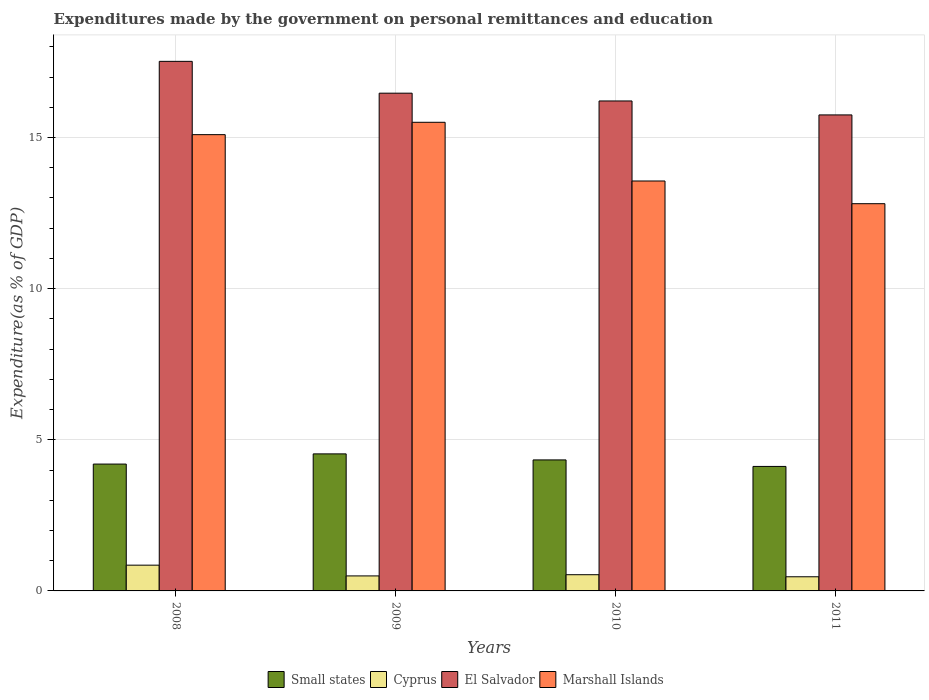How many bars are there on the 4th tick from the left?
Ensure brevity in your answer.  4. How many bars are there on the 1st tick from the right?
Your answer should be compact. 4. What is the expenditures made by the government on personal remittances and education in El Salvador in 2011?
Provide a succinct answer. 15.75. Across all years, what is the maximum expenditures made by the government on personal remittances and education in Small states?
Offer a very short reply. 4.53. Across all years, what is the minimum expenditures made by the government on personal remittances and education in Small states?
Give a very brief answer. 4.12. In which year was the expenditures made by the government on personal remittances and education in Cyprus minimum?
Provide a succinct answer. 2011. What is the total expenditures made by the government on personal remittances and education in El Salvador in the graph?
Make the answer very short. 65.95. What is the difference between the expenditures made by the government on personal remittances and education in Cyprus in 2009 and that in 2011?
Keep it short and to the point. 0.03. What is the difference between the expenditures made by the government on personal remittances and education in Marshall Islands in 2011 and the expenditures made by the government on personal remittances and education in El Salvador in 2010?
Offer a very short reply. -3.4. What is the average expenditures made by the government on personal remittances and education in Small states per year?
Offer a very short reply. 4.3. In the year 2011, what is the difference between the expenditures made by the government on personal remittances and education in Small states and expenditures made by the government on personal remittances and education in Cyprus?
Keep it short and to the point. 3.65. In how many years, is the expenditures made by the government on personal remittances and education in El Salvador greater than 10 %?
Your answer should be very brief. 4. What is the ratio of the expenditures made by the government on personal remittances and education in Cyprus in 2009 to that in 2011?
Offer a terse response. 1.06. Is the expenditures made by the government on personal remittances and education in El Salvador in 2008 less than that in 2011?
Provide a short and direct response. No. Is the difference between the expenditures made by the government on personal remittances and education in Small states in 2009 and 2010 greater than the difference between the expenditures made by the government on personal remittances and education in Cyprus in 2009 and 2010?
Your answer should be compact. Yes. What is the difference between the highest and the second highest expenditures made by the government on personal remittances and education in Marshall Islands?
Offer a terse response. 0.41. What is the difference between the highest and the lowest expenditures made by the government on personal remittances and education in Marshall Islands?
Your answer should be compact. 2.69. Is it the case that in every year, the sum of the expenditures made by the government on personal remittances and education in El Salvador and expenditures made by the government on personal remittances and education in Small states is greater than the sum of expenditures made by the government on personal remittances and education in Marshall Islands and expenditures made by the government on personal remittances and education in Cyprus?
Make the answer very short. Yes. What does the 3rd bar from the left in 2009 represents?
Keep it short and to the point. El Salvador. What does the 2nd bar from the right in 2009 represents?
Provide a short and direct response. El Salvador. Where does the legend appear in the graph?
Your answer should be compact. Bottom center. How are the legend labels stacked?
Give a very brief answer. Horizontal. What is the title of the graph?
Ensure brevity in your answer.  Expenditures made by the government on personal remittances and education. Does "Egypt, Arab Rep." appear as one of the legend labels in the graph?
Ensure brevity in your answer.  No. What is the label or title of the Y-axis?
Your answer should be compact. Expenditure(as % of GDP). What is the Expenditure(as % of GDP) of Small states in 2008?
Offer a terse response. 4.2. What is the Expenditure(as % of GDP) of Cyprus in 2008?
Your answer should be very brief. 0.85. What is the Expenditure(as % of GDP) in El Salvador in 2008?
Keep it short and to the point. 17.52. What is the Expenditure(as % of GDP) of Marshall Islands in 2008?
Give a very brief answer. 15.1. What is the Expenditure(as % of GDP) in Small states in 2009?
Provide a short and direct response. 4.53. What is the Expenditure(as % of GDP) of Cyprus in 2009?
Make the answer very short. 0.5. What is the Expenditure(as % of GDP) in El Salvador in 2009?
Your response must be concise. 16.47. What is the Expenditure(as % of GDP) of Marshall Islands in 2009?
Your response must be concise. 15.5. What is the Expenditure(as % of GDP) in Small states in 2010?
Your answer should be very brief. 4.33. What is the Expenditure(as % of GDP) of Cyprus in 2010?
Make the answer very short. 0.54. What is the Expenditure(as % of GDP) of El Salvador in 2010?
Your answer should be compact. 16.21. What is the Expenditure(as % of GDP) in Marshall Islands in 2010?
Provide a succinct answer. 13.56. What is the Expenditure(as % of GDP) in Small states in 2011?
Offer a very short reply. 4.12. What is the Expenditure(as % of GDP) of Cyprus in 2011?
Offer a very short reply. 0.47. What is the Expenditure(as % of GDP) in El Salvador in 2011?
Keep it short and to the point. 15.75. What is the Expenditure(as % of GDP) of Marshall Islands in 2011?
Keep it short and to the point. 12.81. Across all years, what is the maximum Expenditure(as % of GDP) in Small states?
Your answer should be compact. 4.53. Across all years, what is the maximum Expenditure(as % of GDP) in Cyprus?
Offer a terse response. 0.85. Across all years, what is the maximum Expenditure(as % of GDP) in El Salvador?
Offer a terse response. 17.52. Across all years, what is the maximum Expenditure(as % of GDP) in Marshall Islands?
Offer a very short reply. 15.5. Across all years, what is the minimum Expenditure(as % of GDP) in Small states?
Keep it short and to the point. 4.12. Across all years, what is the minimum Expenditure(as % of GDP) of Cyprus?
Offer a terse response. 0.47. Across all years, what is the minimum Expenditure(as % of GDP) of El Salvador?
Ensure brevity in your answer.  15.75. Across all years, what is the minimum Expenditure(as % of GDP) of Marshall Islands?
Your response must be concise. 12.81. What is the total Expenditure(as % of GDP) of Small states in the graph?
Your answer should be compact. 17.18. What is the total Expenditure(as % of GDP) in Cyprus in the graph?
Offer a terse response. 2.35. What is the total Expenditure(as % of GDP) of El Salvador in the graph?
Offer a very short reply. 65.95. What is the total Expenditure(as % of GDP) in Marshall Islands in the graph?
Your response must be concise. 56.97. What is the difference between the Expenditure(as % of GDP) in Small states in 2008 and that in 2009?
Give a very brief answer. -0.34. What is the difference between the Expenditure(as % of GDP) of Cyprus in 2008 and that in 2009?
Make the answer very short. 0.36. What is the difference between the Expenditure(as % of GDP) of El Salvador in 2008 and that in 2009?
Provide a succinct answer. 1.05. What is the difference between the Expenditure(as % of GDP) of Marshall Islands in 2008 and that in 2009?
Provide a succinct answer. -0.41. What is the difference between the Expenditure(as % of GDP) in Small states in 2008 and that in 2010?
Ensure brevity in your answer.  -0.14. What is the difference between the Expenditure(as % of GDP) in Cyprus in 2008 and that in 2010?
Your response must be concise. 0.32. What is the difference between the Expenditure(as % of GDP) of El Salvador in 2008 and that in 2010?
Your answer should be compact. 1.31. What is the difference between the Expenditure(as % of GDP) in Marshall Islands in 2008 and that in 2010?
Offer a very short reply. 1.53. What is the difference between the Expenditure(as % of GDP) in Small states in 2008 and that in 2011?
Make the answer very short. 0.08. What is the difference between the Expenditure(as % of GDP) in Cyprus in 2008 and that in 2011?
Provide a short and direct response. 0.38. What is the difference between the Expenditure(as % of GDP) of El Salvador in 2008 and that in 2011?
Your answer should be very brief. 1.77. What is the difference between the Expenditure(as % of GDP) in Marshall Islands in 2008 and that in 2011?
Make the answer very short. 2.28. What is the difference between the Expenditure(as % of GDP) of Small states in 2009 and that in 2010?
Give a very brief answer. 0.2. What is the difference between the Expenditure(as % of GDP) of Cyprus in 2009 and that in 2010?
Offer a very short reply. -0.04. What is the difference between the Expenditure(as % of GDP) in El Salvador in 2009 and that in 2010?
Your response must be concise. 0.26. What is the difference between the Expenditure(as % of GDP) in Marshall Islands in 2009 and that in 2010?
Make the answer very short. 1.94. What is the difference between the Expenditure(as % of GDP) of Small states in 2009 and that in 2011?
Make the answer very short. 0.42. What is the difference between the Expenditure(as % of GDP) of Cyprus in 2009 and that in 2011?
Offer a terse response. 0.03. What is the difference between the Expenditure(as % of GDP) in El Salvador in 2009 and that in 2011?
Offer a very short reply. 0.72. What is the difference between the Expenditure(as % of GDP) of Marshall Islands in 2009 and that in 2011?
Provide a succinct answer. 2.69. What is the difference between the Expenditure(as % of GDP) in Small states in 2010 and that in 2011?
Offer a very short reply. 0.22. What is the difference between the Expenditure(as % of GDP) of Cyprus in 2010 and that in 2011?
Offer a very short reply. 0.07. What is the difference between the Expenditure(as % of GDP) of El Salvador in 2010 and that in 2011?
Ensure brevity in your answer.  0.46. What is the difference between the Expenditure(as % of GDP) of Marshall Islands in 2010 and that in 2011?
Give a very brief answer. 0.75. What is the difference between the Expenditure(as % of GDP) of Small states in 2008 and the Expenditure(as % of GDP) of Cyprus in 2009?
Your answer should be very brief. 3.7. What is the difference between the Expenditure(as % of GDP) of Small states in 2008 and the Expenditure(as % of GDP) of El Salvador in 2009?
Offer a very short reply. -12.27. What is the difference between the Expenditure(as % of GDP) of Small states in 2008 and the Expenditure(as % of GDP) of Marshall Islands in 2009?
Make the answer very short. -11.31. What is the difference between the Expenditure(as % of GDP) in Cyprus in 2008 and the Expenditure(as % of GDP) in El Salvador in 2009?
Your answer should be very brief. -15.62. What is the difference between the Expenditure(as % of GDP) of Cyprus in 2008 and the Expenditure(as % of GDP) of Marshall Islands in 2009?
Your answer should be compact. -14.65. What is the difference between the Expenditure(as % of GDP) of El Salvador in 2008 and the Expenditure(as % of GDP) of Marshall Islands in 2009?
Your response must be concise. 2.02. What is the difference between the Expenditure(as % of GDP) of Small states in 2008 and the Expenditure(as % of GDP) of Cyprus in 2010?
Make the answer very short. 3.66. What is the difference between the Expenditure(as % of GDP) of Small states in 2008 and the Expenditure(as % of GDP) of El Salvador in 2010?
Your response must be concise. -12.01. What is the difference between the Expenditure(as % of GDP) of Small states in 2008 and the Expenditure(as % of GDP) of Marshall Islands in 2010?
Provide a succinct answer. -9.37. What is the difference between the Expenditure(as % of GDP) in Cyprus in 2008 and the Expenditure(as % of GDP) in El Salvador in 2010?
Offer a terse response. -15.36. What is the difference between the Expenditure(as % of GDP) of Cyprus in 2008 and the Expenditure(as % of GDP) of Marshall Islands in 2010?
Ensure brevity in your answer.  -12.71. What is the difference between the Expenditure(as % of GDP) in El Salvador in 2008 and the Expenditure(as % of GDP) in Marshall Islands in 2010?
Keep it short and to the point. 3.96. What is the difference between the Expenditure(as % of GDP) in Small states in 2008 and the Expenditure(as % of GDP) in Cyprus in 2011?
Provide a short and direct response. 3.73. What is the difference between the Expenditure(as % of GDP) of Small states in 2008 and the Expenditure(as % of GDP) of El Salvador in 2011?
Provide a succinct answer. -11.55. What is the difference between the Expenditure(as % of GDP) in Small states in 2008 and the Expenditure(as % of GDP) in Marshall Islands in 2011?
Provide a succinct answer. -8.61. What is the difference between the Expenditure(as % of GDP) in Cyprus in 2008 and the Expenditure(as % of GDP) in El Salvador in 2011?
Give a very brief answer. -14.9. What is the difference between the Expenditure(as % of GDP) of Cyprus in 2008 and the Expenditure(as % of GDP) of Marshall Islands in 2011?
Your answer should be compact. -11.96. What is the difference between the Expenditure(as % of GDP) in El Salvador in 2008 and the Expenditure(as % of GDP) in Marshall Islands in 2011?
Make the answer very short. 4.71. What is the difference between the Expenditure(as % of GDP) of Small states in 2009 and the Expenditure(as % of GDP) of Cyprus in 2010?
Offer a terse response. 4. What is the difference between the Expenditure(as % of GDP) of Small states in 2009 and the Expenditure(as % of GDP) of El Salvador in 2010?
Offer a terse response. -11.68. What is the difference between the Expenditure(as % of GDP) in Small states in 2009 and the Expenditure(as % of GDP) in Marshall Islands in 2010?
Offer a terse response. -9.03. What is the difference between the Expenditure(as % of GDP) in Cyprus in 2009 and the Expenditure(as % of GDP) in El Salvador in 2010?
Offer a very short reply. -15.71. What is the difference between the Expenditure(as % of GDP) of Cyprus in 2009 and the Expenditure(as % of GDP) of Marshall Islands in 2010?
Give a very brief answer. -13.07. What is the difference between the Expenditure(as % of GDP) in El Salvador in 2009 and the Expenditure(as % of GDP) in Marshall Islands in 2010?
Keep it short and to the point. 2.91. What is the difference between the Expenditure(as % of GDP) in Small states in 2009 and the Expenditure(as % of GDP) in Cyprus in 2011?
Keep it short and to the point. 4.07. What is the difference between the Expenditure(as % of GDP) in Small states in 2009 and the Expenditure(as % of GDP) in El Salvador in 2011?
Ensure brevity in your answer.  -11.21. What is the difference between the Expenditure(as % of GDP) in Small states in 2009 and the Expenditure(as % of GDP) in Marshall Islands in 2011?
Your answer should be compact. -8.28. What is the difference between the Expenditure(as % of GDP) in Cyprus in 2009 and the Expenditure(as % of GDP) in El Salvador in 2011?
Offer a very short reply. -15.25. What is the difference between the Expenditure(as % of GDP) of Cyprus in 2009 and the Expenditure(as % of GDP) of Marshall Islands in 2011?
Make the answer very short. -12.31. What is the difference between the Expenditure(as % of GDP) in El Salvador in 2009 and the Expenditure(as % of GDP) in Marshall Islands in 2011?
Keep it short and to the point. 3.66. What is the difference between the Expenditure(as % of GDP) in Small states in 2010 and the Expenditure(as % of GDP) in Cyprus in 2011?
Offer a very short reply. 3.87. What is the difference between the Expenditure(as % of GDP) of Small states in 2010 and the Expenditure(as % of GDP) of El Salvador in 2011?
Offer a terse response. -11.41. What is the difference between the Expenditure(as % of GDP) in Small states in 2010 and the Expenditure(as % of GDP) in Marshall Islands in 2011?
Offer a very short reply. -8.48. What is the difference between the Expenditure(as % of GDP) in Cyprus in 2010 and the Expenditure(as % of GDP) in El Salvador in 2011?
Make the answer very short. -15.21. What is the difference between the Expenditure(as % of GDP) of Cyprus in 2010 and the Expenditure(as % of GDP) of Marshall Islands in 2011?
Provide a succinct answer. -12.27. What is the difference between the Expenditure(as % of GDP) in El Salvador in 2010 and the Expenditure(as % of GDP) in Marshall Islands in 2011?
Keep it short and to the point. 3.4. What is the average Expenditure(as % of GDP) of Small states per year?
Provide a short and direct response. 4.3. What is the average Expenditure(as % of GDP) in Cyprus per year?
Keep it short and to the point. 0.59. What is the average Expenditure(as % of GDP) of El Salvador per year?
Offer a very short reply. 16.49. What is the average Expenditure(as % of GDP) in Marshall Islands per year?
Make the answer very short. 14.24. In the year 2008, what is the difference between the Expenditure(as % of GDP) of Small states and Expenditure(as % of GDP) of Cyprus?
Your answer should be compact. 3.34. In the year 2008, what is the difference between the Expenditure(as % of GDP) of Small states and Expenditure(as % of GDP) of El Salvador?
Your answer should be compact. -13.32. In the year 2008, what is the difference between the Expenditure(as % of GDP) of Small states and Expenditure(as % of GDP) of Marshall Islands?
Your answer should be compact. -10.9. In the year 2008, what is the difference between the Expenditure(as % of GDP) of Cyprus and Expenditure(as % of GDP) of El Salvador?
Your response must be concise. -16.67. In the year 2008, what is the difference between the Expenditure(as % of GDP) in Cyprus and Expenditure(as % of GDP) in Marshall Islands?
Make the answer very short. -14.24. In the year 2008, what is the difference between the Expenditure(as % of GDP) of El Salvador and Expenditure(as % of GDP) of Marshall Islands?
Offer a terse response. 2.42. In the year 2009, what is the difference between the Expenditure(as % of GDP) in Small states and Expenditure(as % of GDP) in Cyprus?
Offer a very short reply. 4.04. In the year 2009, what is the difference between the Expenditure(as % of GDP) of Small states and Expenditure(as % of GDP) of El Salvador?
Offer a terse response. -11.93. In the year 2009, what is the difference between the Expenditure(as % of GDP) in Small states and Expenditure(as % of GDP) in Marshall Islands?
Keep it short and to the point. -10.97. In the year 2009, what is the difference between the Expenditure(as % of GDP) in Cyprus and Expenditure(as % of GDP) in El Salvador?
Provide a succinct answer. -15.97. In the year 2009, what is the difference between the Expenditure(as % of GDP) in Cyprus and Expenditure(as % of GDP) in Marshall Islands?
Make the answer very short. -15.01. In the year 2009, what is the difference between the Expenditure(as % of GDP) of El Salvador and Expenditure(as % of GDP) of Marshall Islands?
Provide a succinct answer. 0.96. In the year 2010, what is the difference between the Expenditure(as % of GDP) in Small states and Expenditure(as % of GDP) in Cyprus?
Give a very brief answer. 3.8. In the year 2010, what is the difference between the Expenditure(as % of GDP) in Small states and Expenditure(as % of GDP) in El Salvador?
Provide a succinct answer. -11.88. In the year 2010, what is the difference between the Expenditure(as % of GDP) of Small states and Expenditure(as % of GDP) of Marshall Islands?
Ensure brevity in your answer.  -9.23. In the year 2010, what is the difference between the Expenditure(as % of GDP) in Cyprus and Expenditure(as % of GDP) in El Salvador?
Your answer should be compact. -15.67. In the year 2010, what is the difference between the Expenditure(as % of GDP) of Cyprus and Expenditure(as % of GDP) of Marshall Islands?
Ensure brevity in your answer.  -13.03. In the year 2010, what is the difference between the Expenditure(as % of GDP) of El Salvador and Expenditure(as % of GDP) of Marshall Islands?
Your answer should be compact. 2.65. In the year 2011, what is the difference between the Expenditure(as % of GDP) of Small states and Expenditure(as % of GDP) of Cyprus?
Offer a very short reply. 3.65. In the year 2011, what is the difference between the Expenditure(as % of GDP) of Small states and Expenditure(as % of GDP) of El Salvador?
Offer a terse response. -11.63. In the year 2011, what is the difference between the Expenditure(as % of GDP) of Small states and Expenditure(as % of GDP) of Marshall Islands?
Make the answer very short. -8.69. In the year 2011, what is the difference between the Expenditure(as % of GDP) in Cyprus and Expenditure(as % of GDP) in El Salvador?
Your answer should be compact. -15.28. In the year 2011, what is the difference between the Expenditure(as % of GDP) of Cyprus and Expenditure(as % of GDP) of Marshall Islands?
Offer a very short reply. -12.34. In the year 2011, what is the difference between the Expenditure(as % of GDP) in El Salvador and Expenditure(as % of GDP) in Marshall Islands?
Offer a very short reply. 2.94. What is the ratio of the Expenditure(as % of GDP) in Small states in 2008 to that in 2009?
Your response must be concise. 0.93. What is the ratio of the Expenditure(as % of GDP) of Cyprus in 2008 to that in 2009?
Your answer should be compact. 1.72. What is the ratio of the Expenditure(as % of GDP) in El Salvador in 2008 to that in 2009?
Offer a very short reply. 1.06. What is the ratio of the Expenditure(as % of GDP) of Marshall Islands in 2008 to that in 2009?
Keep it short and to the point. 0.97. What is the ratio of the Expenditure(as % of GDP) of Small states in 2008 to that in 2010?
Your answer should be very brief. 0.97. What is the ratio of the Expenditure(as % of GDP) of Cyprus in 2008 to that in 2010?
Make the answer very short. 1.59. What is the ratio of the Expenditure(as % of GDP) in El Salvador in 2008 to that in 2010?
Your answer should be compact. 1.08. What is the ratio of the Expenditure(as % of GDP) in Marshall Islands in 2008 to that in 2010?
Give a very brief answer. 1.11. What is the ratio of the Expenditure(as % of GDP) of Small states in 2008 to that in 2011?
Ensure brevity in your answer.  1.02. What is the ratio of the Expenditure(as % of GDP) of Cyprus in 2008 to that in 2011?
Make the answer very short. 1.82. What is the ratio of the Expenditure(as % of GDP) in El Salvador in 2008 to that in 2011?
Offer a terse response. 1.11. What is the ratio of the Expenditure(as % of GDP) of Marshall Islands in 2008 to that in 2011?
Offer a very short reply. 1.18. What is the ratio of the Expenditure(as % of GDP) of Small states in 2009 to that in 2010?
Ensure brevity in your answer.  1.05. What is the ratio of the Expenditure(as % of GDP) of Cyprus in 2009 to that in 2010?
Provide a short and direct response. 0.93. What is the ratio of the Expenditure(as % of GDP) of El Salvador in 2009 to that in 2010?
Offer a very short reply. 1.02. What is the ratio of the Expenditure(as % of GDP) in Marshall Islands in 2009 to that in 2010?
Your response must be concise. 1.14. What is the ratio of the Expenditure(as % of GDP) of Small states in 2009 to that in 2011?
Give a very brief answer. 1.1. What is the ratio of the Expenditure(as % of GDP) in Cyprus in 2009 to that in 2011?
Make the answer very short. 1.06. What is the ratio of the Expenditure(as % of GDP) of El Salvador in 2009 to that in 2011?
Your answer should be very brief. 1.05. What is the ratio of the Expenditure(as % of GDP) in Marshall Islands in 2009 to that in 2011?
Provide a short and direct response. 1.21. What is the ratio of the Expenditure(as % of GDP) in Small states in 2010 to that in 2011?
Offer a very short reply. 1.05. What is the ratio of the Expenditure(as % of GDP) in Cyprus in 2010 to that in 2011?
Your answer should be compact. 1.15. What is the ratio of the Expenditure(as % of GDP) in El Salvador in 2010 to that in 2011?
Provide a succinct answer. 1.03. What is the ratio of the Expenditure(as % of GDP) in Marshall Islands in 2010 to that in 2011?
Ensure brevity in your answer.  1.06. What is the difference between the highest and the second highest Expenditure(as % of GDP) in Small states?
Your response must be concise. 0.2. What is the difference between the highest and the second highest Expenditure(as % of GDP) of Cyprus?
Keep it short and to the point. 0.32. What is the difference between the highest and the second highest Expenditure(as % of GDP) in El Salvador?
Your answer should be very brief. 1.05. What is the difference between the highest and the second highest Expenditure(as % of GDP) of Marshall Islands?
Ensure brevity in your answer.  0.41. What is the difference between the highest and the lowest Expenditure(as % of GDP) in Small states?
Ensure brevity in your answer.  0.42. What is the difference between the highest and the lowest Expenditure(as % of GDP) of Cyprus?
Your answer should be compact. 0.38. What is the difference between the highest and the lowest Expenditure(as % of GDP) of El Salvador?
Your answer should be compact. 1.77. What is the difference between the highest and the lowest Expenditure(as % of GDP) in Marshall Islands?
Provide a succinct answer. 2.69. 